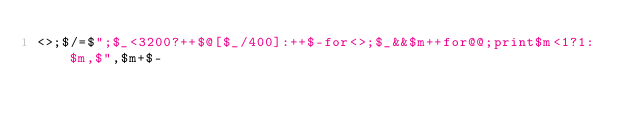<code> <loc_0><loc_0><loc_500><loc_500><_Perl_><>;$/=$";$_<3200?++$@[$_/400]:++$-for<>;$_&&$m++for@@;print$m<1?1:$m,$",$m+$-</code> 